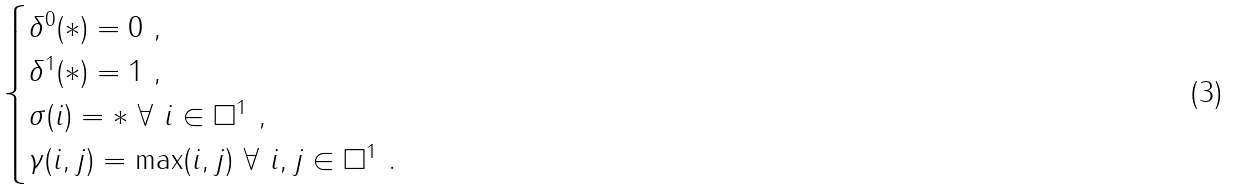<formula> <loc_0><loc_0><loc_500><loc_500>\begin{cases} \delta ^ { 0 } ( * ) = 0 \ , \\ \delta ^ { 1 } ( * ) = 1 \ , \\ \sigma ( i ) = * \ \forall \ i \in \square ^ { 1 } \ , \\ \gamma ( i , j ) = \max ( i , j ) \ \forall \ i , j \in \square ^ { 1 } \ . \end{cases}</formula> 